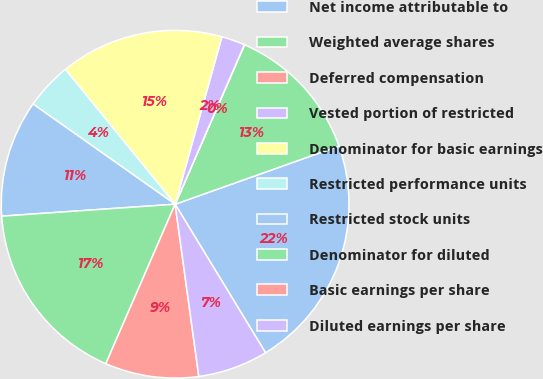Convert chart to OTSL. <chart><loc_0><loc_0><loc_500><loc_500><pie_chart><fcel>Net income attributable to<fcel>Weighted average shares<fcel>Deferred compensation<fcel>Vested portion of restricted<fcel>Denominator for basic earnings<fcel>Restricted performance units<fcel>Restricted stock units<fcel>Denominator for diluted<fcel>Basic earnings per share<fcel>Diluted earnings per share<nl><fcel>21.73%<fcel>13.04%<fcel>0.01%<fcel>2.18%<fcel>15.21%<fcel>4.35%<fcel>10.87%<fcel>17.38%<fcel>8.7%<fcel>6.53%<nl></chart> 